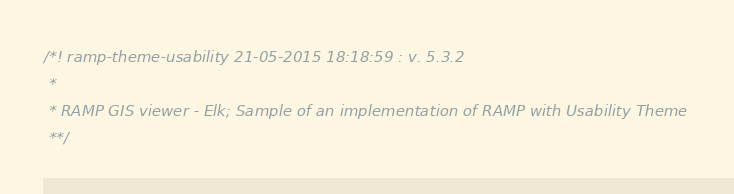<code> <loc_0><loc_0><loc_500><loc_500><_JavaScript_>/*! ramp-theme-usability 21-05-2015 18:18:59 : v. 5.3.2 
 * 
 * RAMP GIS viewer - Elk; Sample of an implementation of RAMP with Usability Theme 
 **/</code> 